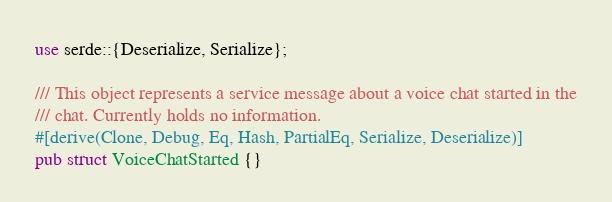<code> <loc_0><loc_0><loc_500><loc_500><_Rust_>use serde::{Deserialize, Serialize};

/// This object represents a service message about a voice chat started in the
/// chat. Currently holds no information.
#[derive(Clone, Debug, Eq, Hash, PartialEq, Serialize, Deserialize)]
pub struct VoiceChatStarted {}
</code> 